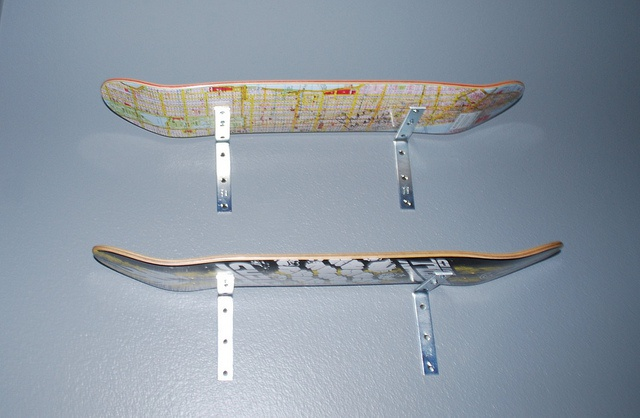Describe the objects in this image and their specific colors. I can see snowboard in gray, darkgray, tan, and lightgray tones, skateboard in gray, darkgray, tan, and lightgray tones, skateboard in gray, darkgray, lightgray, and black tones, and snowboard in gray, darkgray, black, and lightgray tones in this image. 